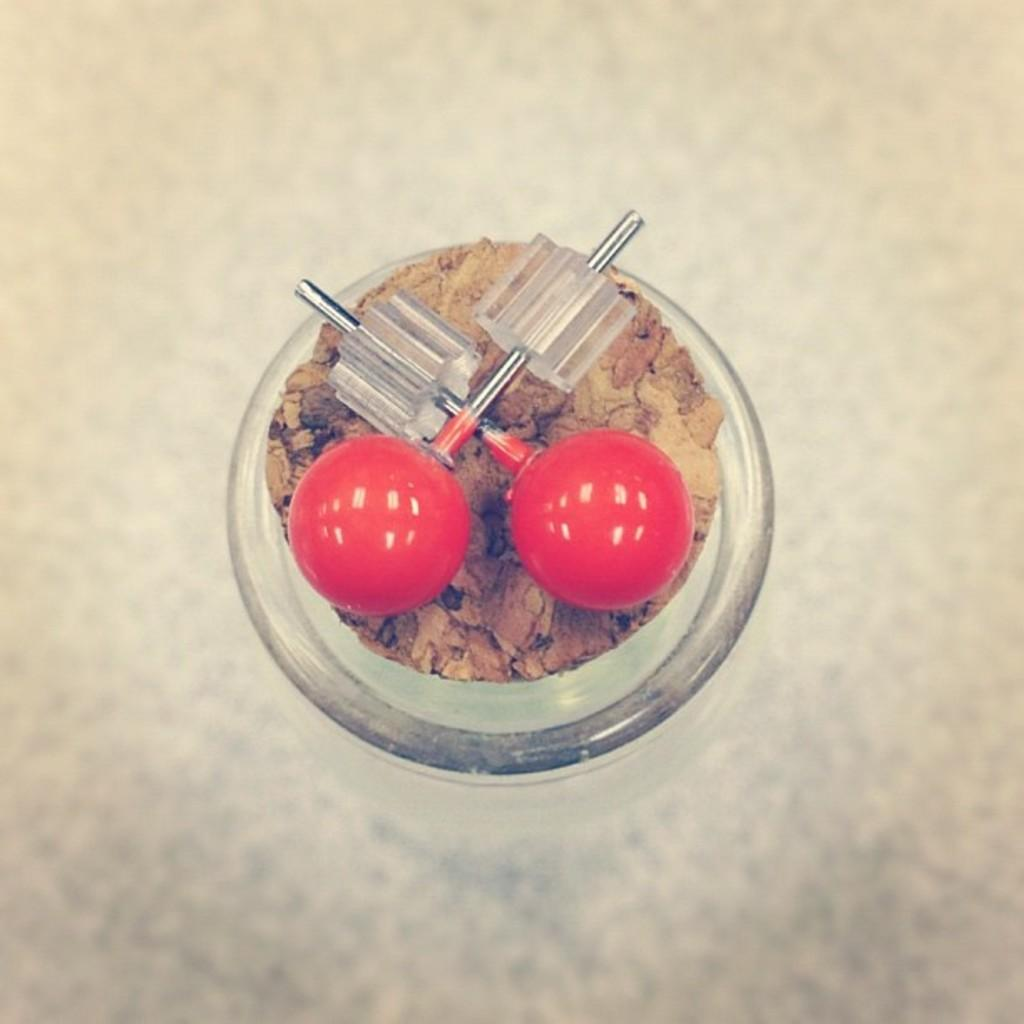What type of objects are in the image? There are red-colored balls in the image. Where are the red-colored balls located? The red-colored balls are on a glass jar. How does the carriage help the balls change their color in the image? There is no carriage present in the image, and the balls do not change color. 